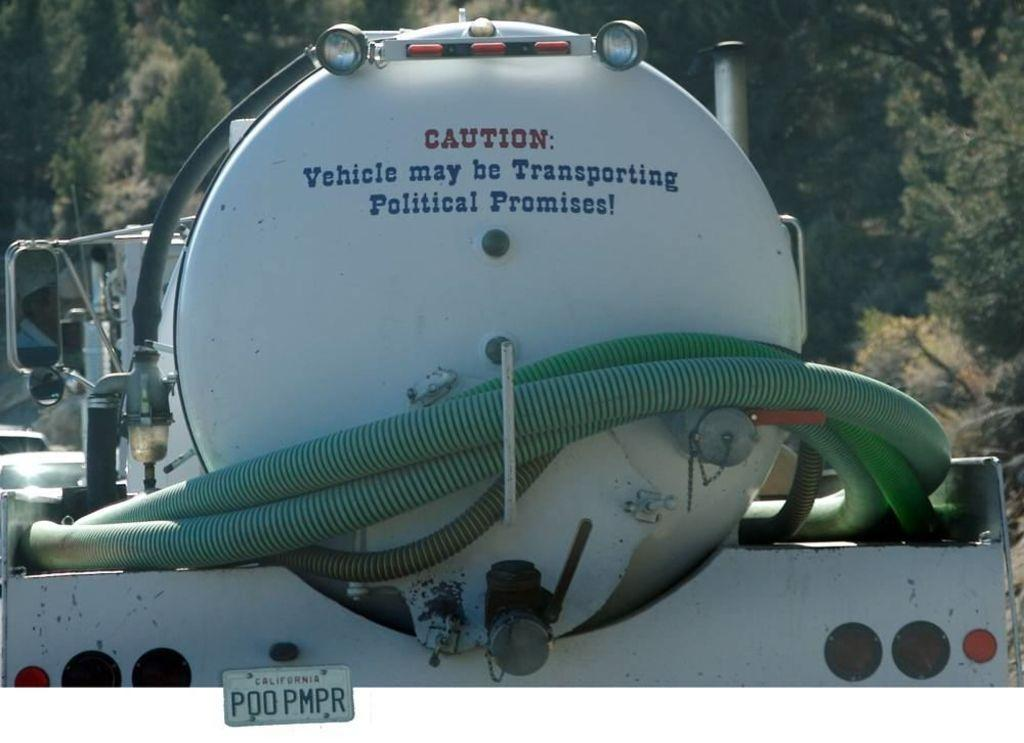What type of vehicle is in the image? There is a vehicle in the image, but the specific type is not mentioned. What features can be seen on the vehicle? The vehicle has pipes, a number plate, mirrors, and objects on it. Can you describe the background of the image? There are trees in the background of the image. How many bears are sitting on the vehicle in the image? There are no bears present in the image. 